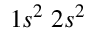Convert formula to latex. <formula><loc_0><loc_0><loc_500><loc_500>1 s ^ { 2 } \, 2 s ^ { 2 }</formula> 